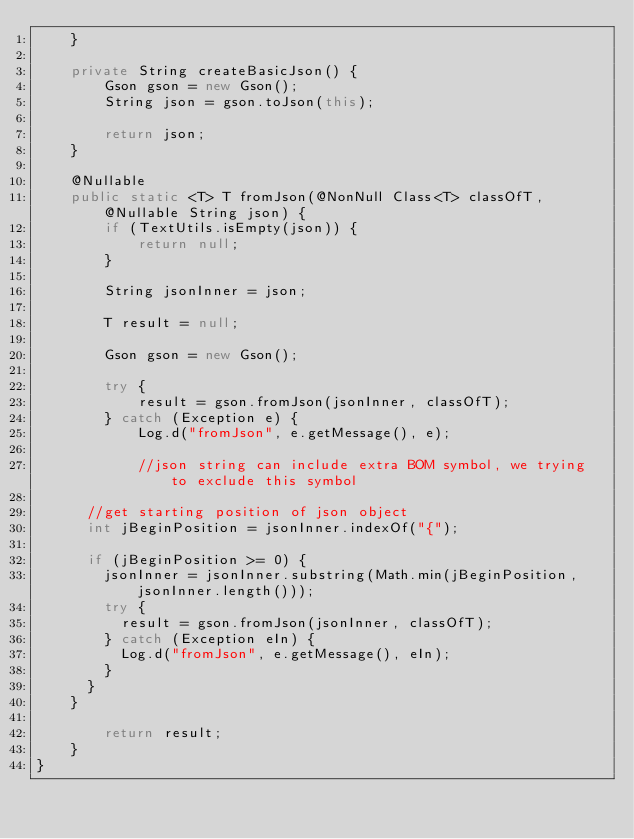Convert code to text. <code><loc_0><loc_0><loc_500><loc_500><_Java_>    }

    private String createBasicJson() {
        Gson gson = new Gson();
        String json = gson.toJson(this);

        return json;
    }

    @Nullable
    public static <T> T fromJson(@NonNull Class<T> classOfT, @Nullable String json) {
        if (TextUtils.isEmpty(json)) {
            return null;
        }

        String jsonInner = json;

        T result = null;

        Gson gson = new Gson();

        try {
            result = gson.fromJson(jsonInner, classOfT);
        } catch (Exception e) {
            Log.d("fromJson", e.getMessage(), e);

            //json string can include extra BOM symbol, we trying to exclude this symbol

			//get starting position of json object
			int jBeginPosition = jsonInner.indexOf("{");

			if (jBeginPosition >= 0) {
				jsonInner = jsonInner.substring(Math.min(jBeginPosition, jsonInner.length()));
				try {
					result = gson.fromJson(jsonInner, classOfT);
				} catch (Exception eIn) {
					Log.d("fromJson", e.getMessage(), eIn);
				}
			}
		}

        return result;
    }
}
</code> 